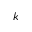<formula> <loc_0><loc_0><loc_500><loc_500>k</formula> 